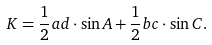Convert formula to latex. <formula><loc_0><loc_0><loc_500><loc_500>K = { \frac { 1 } { 2 } } a d \cdot \sin { A } + { \frac { 1 } { 2 } } b c \cdot \sin { C } .</formula> 